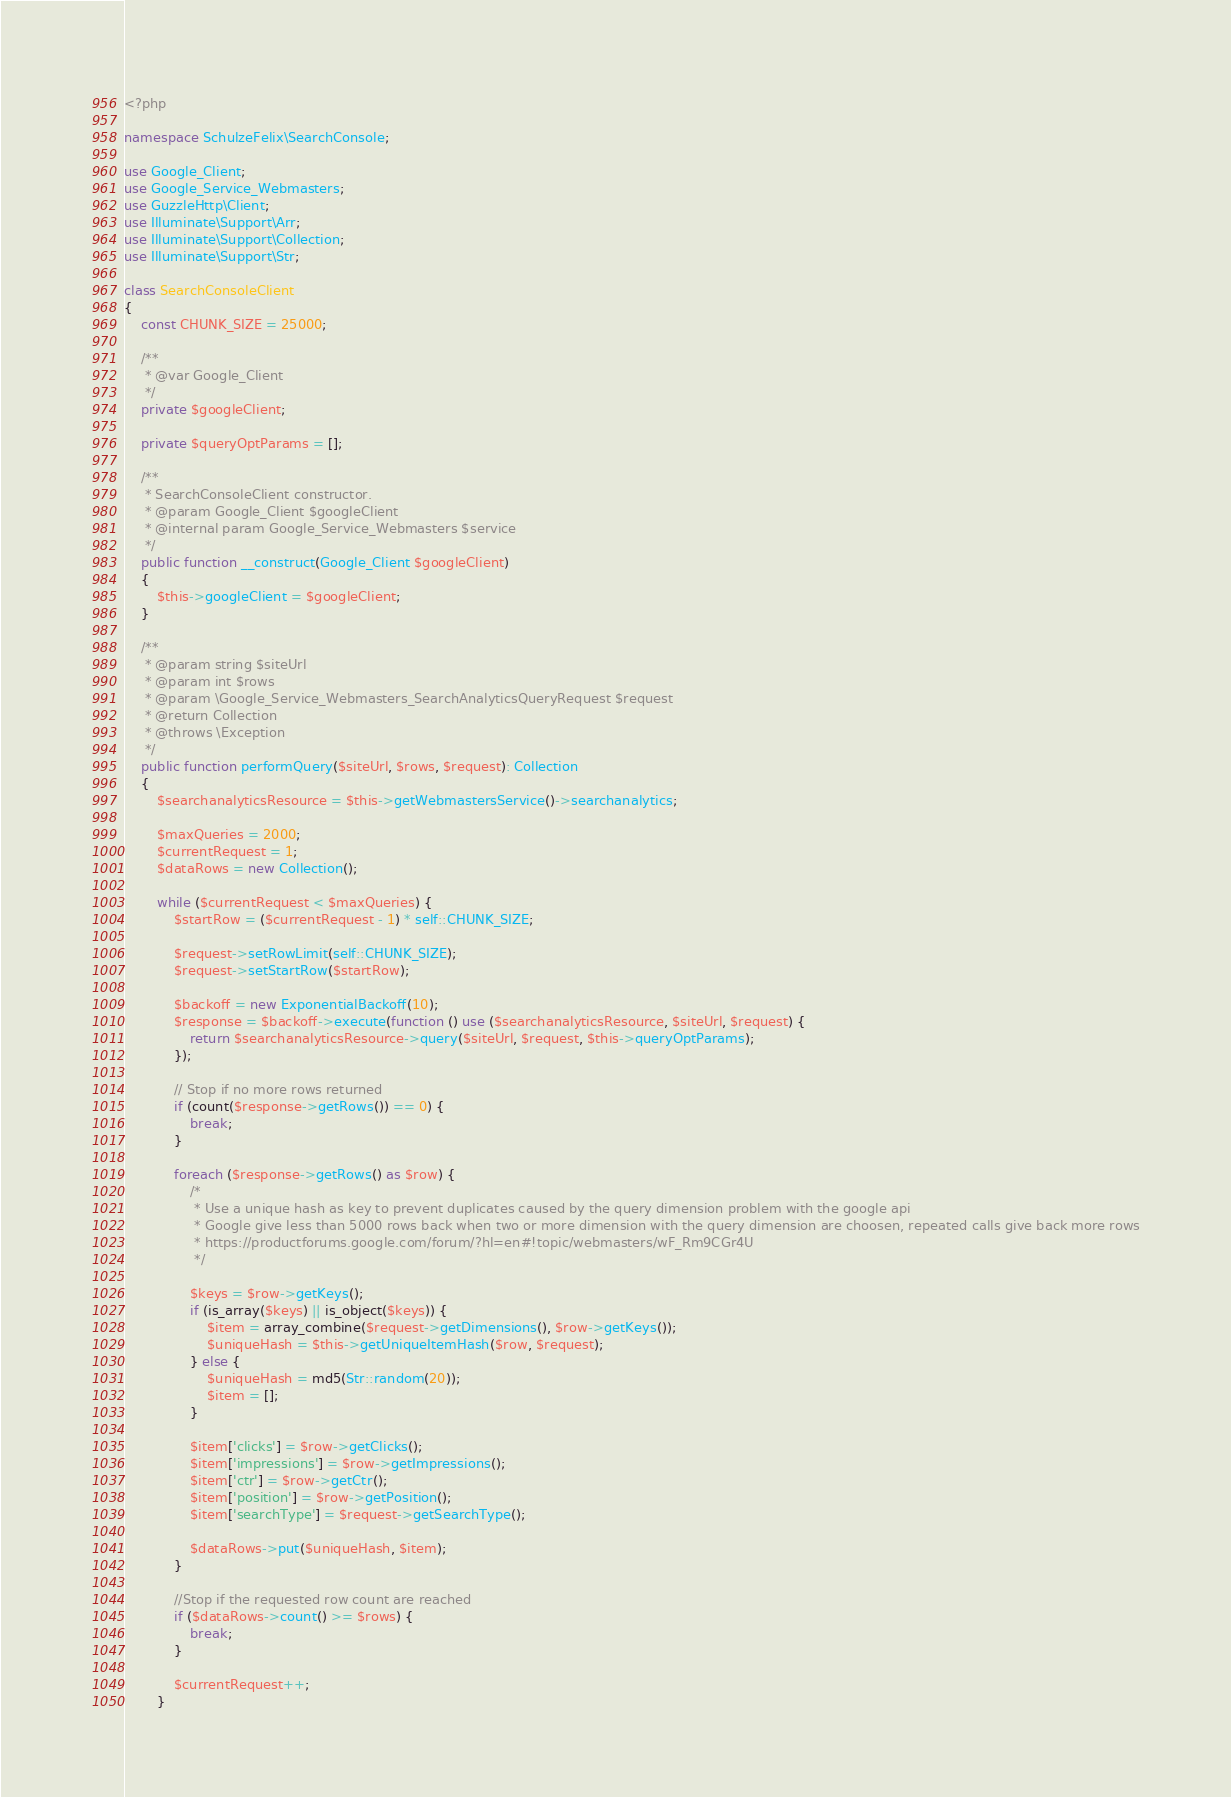<code> <loc_0><loc_0><loc_500><loc_500><_PHP_><?php

namespace SchulzeFelix\SearchConsole;

use Google_Client;
use Google_Service_Webmasters;
use GuzzleHttp\Client;
use Illuminate\Support\Arr;
use Illuminate\Support\Collection;
use Illuminate\Support\Str;

class SearchConsoleClient
{
    const CHUNK_SIZE = 25000;

    /**
     * @var Google_Client
     */
    private $googleClient;

    private $queryOptParams = [];

    /**
     * SearchConsoleClient constructor.
     * @param Google_Client $googleClient
     * @internal param Google_Service_Webmasters $service
     */
    public function __construct(Google_Client $googleClient)
    {
        $this->googleClient = $googleClient;
    }

    /**
     * @param string $siteUrl
     * @param int $rows
     * @param \Google_Service_Webmasters_SearchAnalyticsQueryRequest $request
     * @return Collection
     * @throws \Exception
     */
    public function performQuery($siteUrl, $rows, $request): Collection
    {
        $searchanalyticsResource = $this->getWebmastersService()->searchanalytics;

        $maxQueries = 2000;
        $currentRequest = 1;
        $dataRows = new Collection();

        while ($currentRequest < $maxQueries) {
            $startRow = ($currentRequest - 1) * self::CHUNK_SIZE;

            $request->setRowLimit(self::CHUNK_SIZE);
            $request->setStartRow($startRow);

            $backoff = new ExponentialBackoff(10);
            $response = $backoff->execute(function () use ($searchanalyticsResource, $siteUrl, $request) {
                return $searchanalyticsResource->query($siteUrl, $request, $this->queryOptParams);
            });

            // Stop if no more rows returned
            if (count($response->getRows()) == 0) {
                break;
            }

            foreach ($response->getRows() as $row) {
                /*
                 * Use a unique hash as key to prevent duplicates caused by the query dimension problem with the google api
                 * Google give less than 5000 rows back when two or more dimension with the query dimension are choosen, repeated calls give back more rows
                 * https://productforums.google.com/forum/?hl=en#!topic/webmasters/wF_Rm9CGr4U
                 */

                $keys = $row->getKeys();
                if (is_array($keys) || is_object($keys)) {
                    $item = array_combine($request->getDimensions(), $row->getKeys());
                    $uniqueHash = $this->getUniqueItemHash($row, $request);
                } else {
                    $uniqueHash = md5(Str::random(20));
                    $item = [];
                }

                $item['clicks'] = $row->getClicks();
                $item['impressions'] = $row->getImpressions();
                $item['ctr'] = $row->getCtr();
                $item['position'] = $row->getPosition();
                $item['searchType'] = $request->getSearchType();

                $dataRows->put($uniqueHash, $item);
            }

            //Stop if the requested row count are reached
            if ($dataRows->count() >= $rows) {
                break;
            }

            $currentRequest++;
        }
</code> 